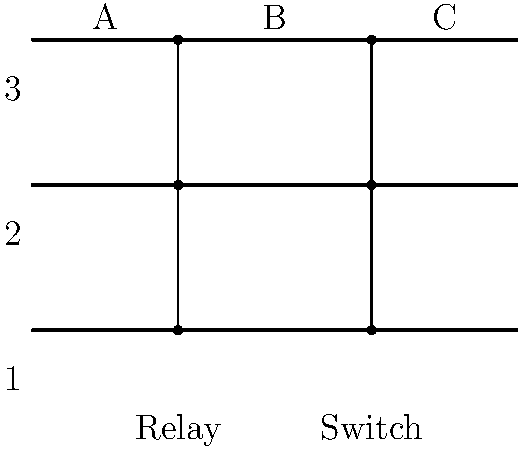In the given aircraft wiring diagram, which component failure would most likely cause a complete loss of power to all three circuits (1, 2, and 3) simultaneously? To answer this question, let's analyze the wiring diagram step-by-step:

1. The diagram shows three horizontal lines representing three separate circuits (1, 2, and 3).

2. There are two vertical components intersecting all three circuits:
   a) A relay at point A
   b) A switch at point B

3. The relay at point A:
   - Relays are typically used to control multiple circuits with a single switch.
   - If the relay fails in the open position, it would disconnect all three circuits simultaneously.

4. The switch at point B:
   - Switches are used to manually control the flow of electricity.
   - A failure of the switch alone would not necessarily affect all three circuits simultaneously, as switches typically control individual circuits.

5. Point C represents the continuation of the circuits, likely to their respective loads or additional components.

6. Given the nature of relays and their ability to control multiple circuits:
   - A failure of the relay at point A is more likely to cause a complete loss of power to all three circuits simultaneously.
   - This is because relays are designed to make or break multiple circuit connections at once.

Therefore, the component most likely to cause a complete loss of power to all three circuits simultaneously if it fails is the relay at point A.
Answer: Relay failure 